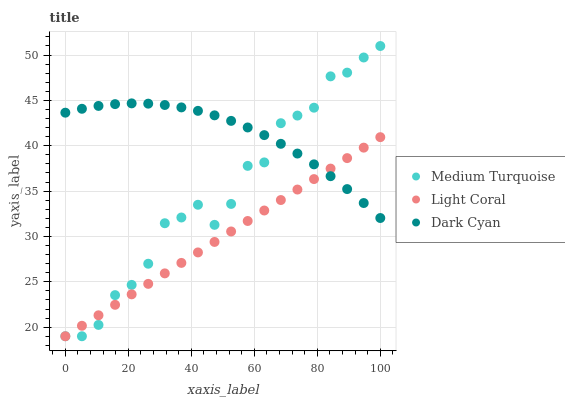Does Light Coral have the minimum area under the curve?
Answer yes or no. Yes. Does Dark Cyan have the maximum area under the curve?
Answer yes or no. Yes. Does Medium Turquoise have the minimum area under the curve?
Answer yes or no. No. Does Medium Turquoise have the maximum area under the curve?
Answer yes or no. No. Is Light Coral the smoothest?
Answer yes or no. Yes. Is Medium Turquoise the roughest?
Answer yes or no. Yes. Is Dark Cyan the smoothest?
Answer yes or no. No. Is Dark Cyan the roughest?
Answer yes or no. No. Does Light Coral have the lowest value?
Answer yes or no. Yes. Does Dark Cyan have the lowest value?
Answer yes or no. No. Does Medium Turquoise have the highest value?
Answer yes or no. Yes. Does Dark Cyan have the highest value?
Answer yes or no. No. Does Light Coral intersect Dark Cyan?
Answer yes or no. Yes. Is Light Coral less than Dark Cyan?
Answer yes or no. No. Is Light Coral greater than Dark Cyan?
Answer yes or no. No. 